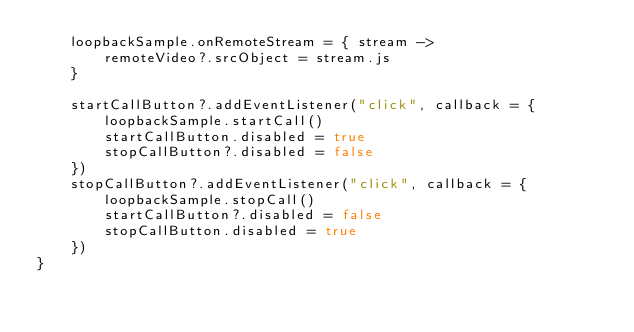<code> <loc_0><loc_0><loc_500><loc_500><_Kotlin_>    loopbackSample.onRemoteStream = { stream ->
        remoteVideo?.srcObject = stream.js
    }

    startCallButton?.addEventListener("click", callback = {
        loopbackSample.startCall()
        startCallButton.disabled = true
        stopCallButton?.disabled = false
    })
    stopCallButton?.addEventListener("click", callback = {
        loopbackSample.stopCall()
        startCallButton?.disabled = false
        stopCallButton.disabled = true
    })
}
</code> 